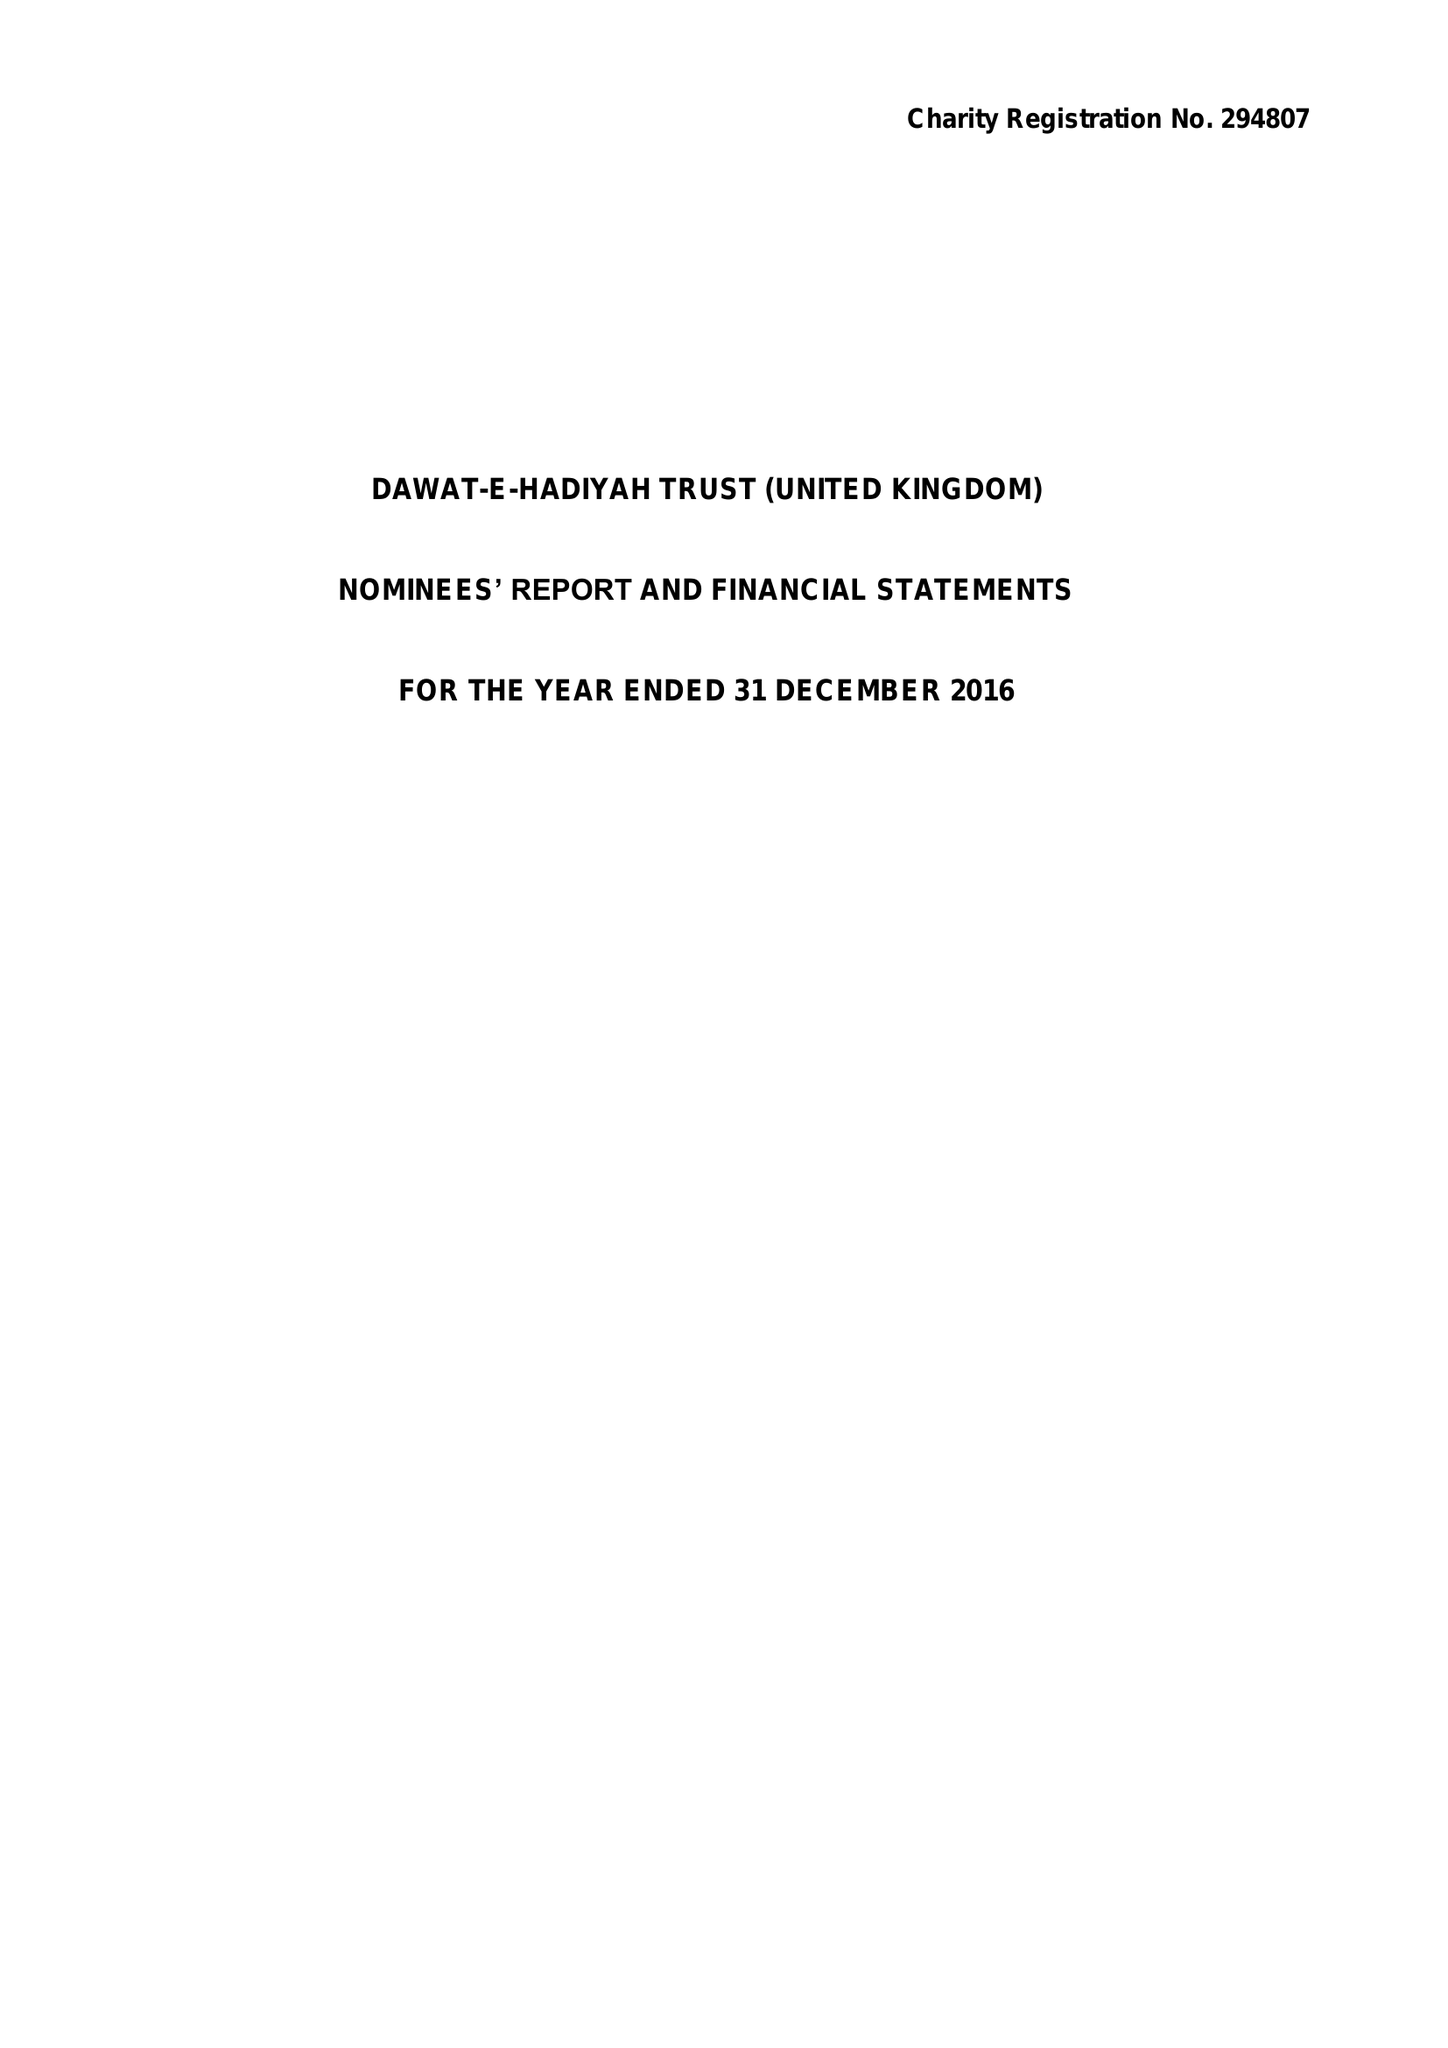What is the value for the income_annually_in_british_pounds?
Answer the question using a single word or phrase. 8273126.00 